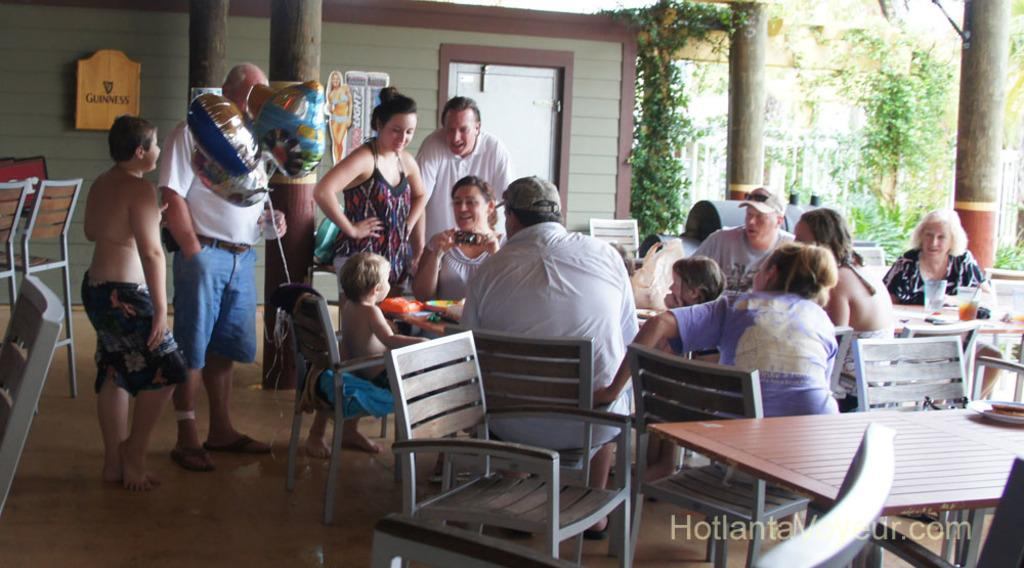What are the people in the image doing? There are many people sitting and some people standing in the image. What is in front of the people? There is a table in front of the people. What type of vegetation can be seen in the image? There are creeps (possibly referring to creepers or vines) and trees present in the image. Can you see a fireman putting out a fire in the image? There is no fireman or fire present in the image. What type of oil is being used by the people in the image? There is no oil or any indication of its use in the image. 